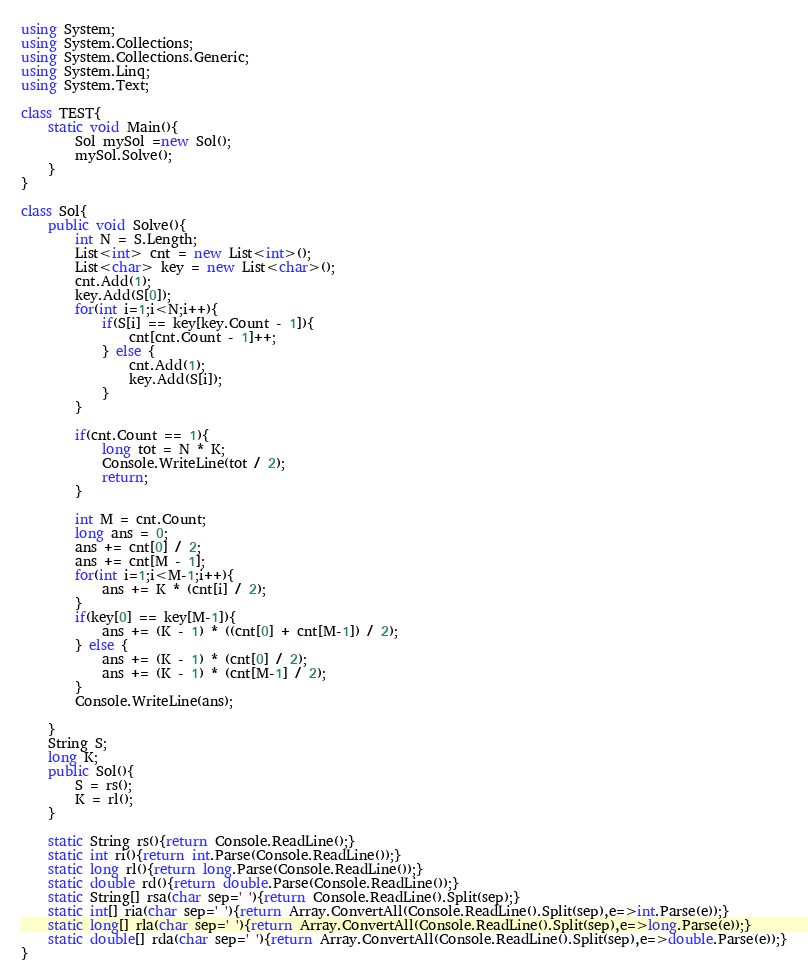Convert code to text. <code><loc_0><loc_0><loc_500><loc_500><_C#_>using System;
using System.Collections;
using System.Collections.Generic;
using System.Linq;
using System.Text;

class TEST{
	static void Main(){
		Sol mySol =new Sol();
		mySol.Solve();
	}
}

class Sol{
	public void Solve(){
		int N = S.Length;
		List<int> cnt = new List<int>();
		List<char> key = new List<char>();
		cnt.Add(1);
		key.Add(S[0]);
		for(int i=1;i<N;i++){
			if(S[i] == key[key.Count - 1]){
				cnt[cnt.Count - 1]++;
			} else {
				cnt.Add(1);
				key.Add(S[i]);
			}
		}
		
		if(cnt.Count == 1){
			long tot = N * K;
			Console.WriteLine(tot / 2);
			return;
		}
		
		int M = cnt.Count;
		long ans = 0;
		ans += cnt[0] / 2;
		ans += cnt[M - 1];
		for(int i=1;i<M-1;i++){
			ans += K * (cnt[i] / 2);
		}
		if(key[0] == key[M-1]){
			ans += (K - 1) * ((cnt[0] + cnt[M-1]) / 2);
		} else {
			ans += (K - 1) * (cnt[0] / 2);
			ans += (K - 1) * (cnt[M-1] / 2);
		}
		Console.WriteLine(ans);
		
	}
	String S;
	long K;
	public Sol(){
		S = rs();
		K = rl();
	}

	static String rs(){return Console.ReadLine();}
	static int ri(){return int.Parse(Console.ReadLine());}
	static long rl(){return long.Parse(Console.ReadLine());}
	static double rd(){return double.Parse(Console.ReadLine());}
	static String[] rsa(char sep=' '){return Console.ReadLine().Split(sep);}
	static int[] ria(char sep=' '){return Array.ConvertAll(Console.ReadLine().Split(sep),e=>int.Parse(e));}
	static long[] rla(char sep=' '){return Array.ConvertAll(Console.ReadLine().Split(sep),e=>long.Parse(e));}
	static double[] rda(char sep=' '){return Array.ConvertAll(Console.ReadLine().Split(sep),e=>double.Parse(e));}
}
</code> 